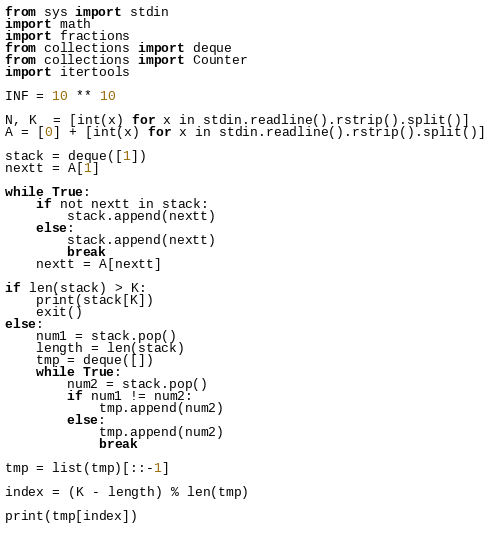Convert code to text. <code><loc_0><loc_0><loc_500><loc_500><_Python_>from sys import stdin
import math
import fractions
from collections import deque
from collections import Counter
import itertools

INF = 10 ** 10

N, K  = [int(x) for x in stdin.readline().rstrip().split()]
A = [0] + [int(x) for x in stdin.readline().rstrip().split()]

stack = deque([1])
nextt = A[1]

while True:
    if not nextt in stack:
        stack.append(nextt)
    else:
        stack.append(nextt)
        break
    nextt = A[nextt]

if len(stack) > K:
    print(stack[K])
    exit()
else:
    num1 = stack.pop()
    length = len(stack)
    tmp = deque([])
    while True:
        num2 = stack.pop()
        if num1 != num2:
            tmp.append(num2)
        else:
            tmp.append(num2)
            break

tmp = list(tmp)[::-1]

index = (K - length) % len(tmp)

print(tmp[index])
    
</code> 